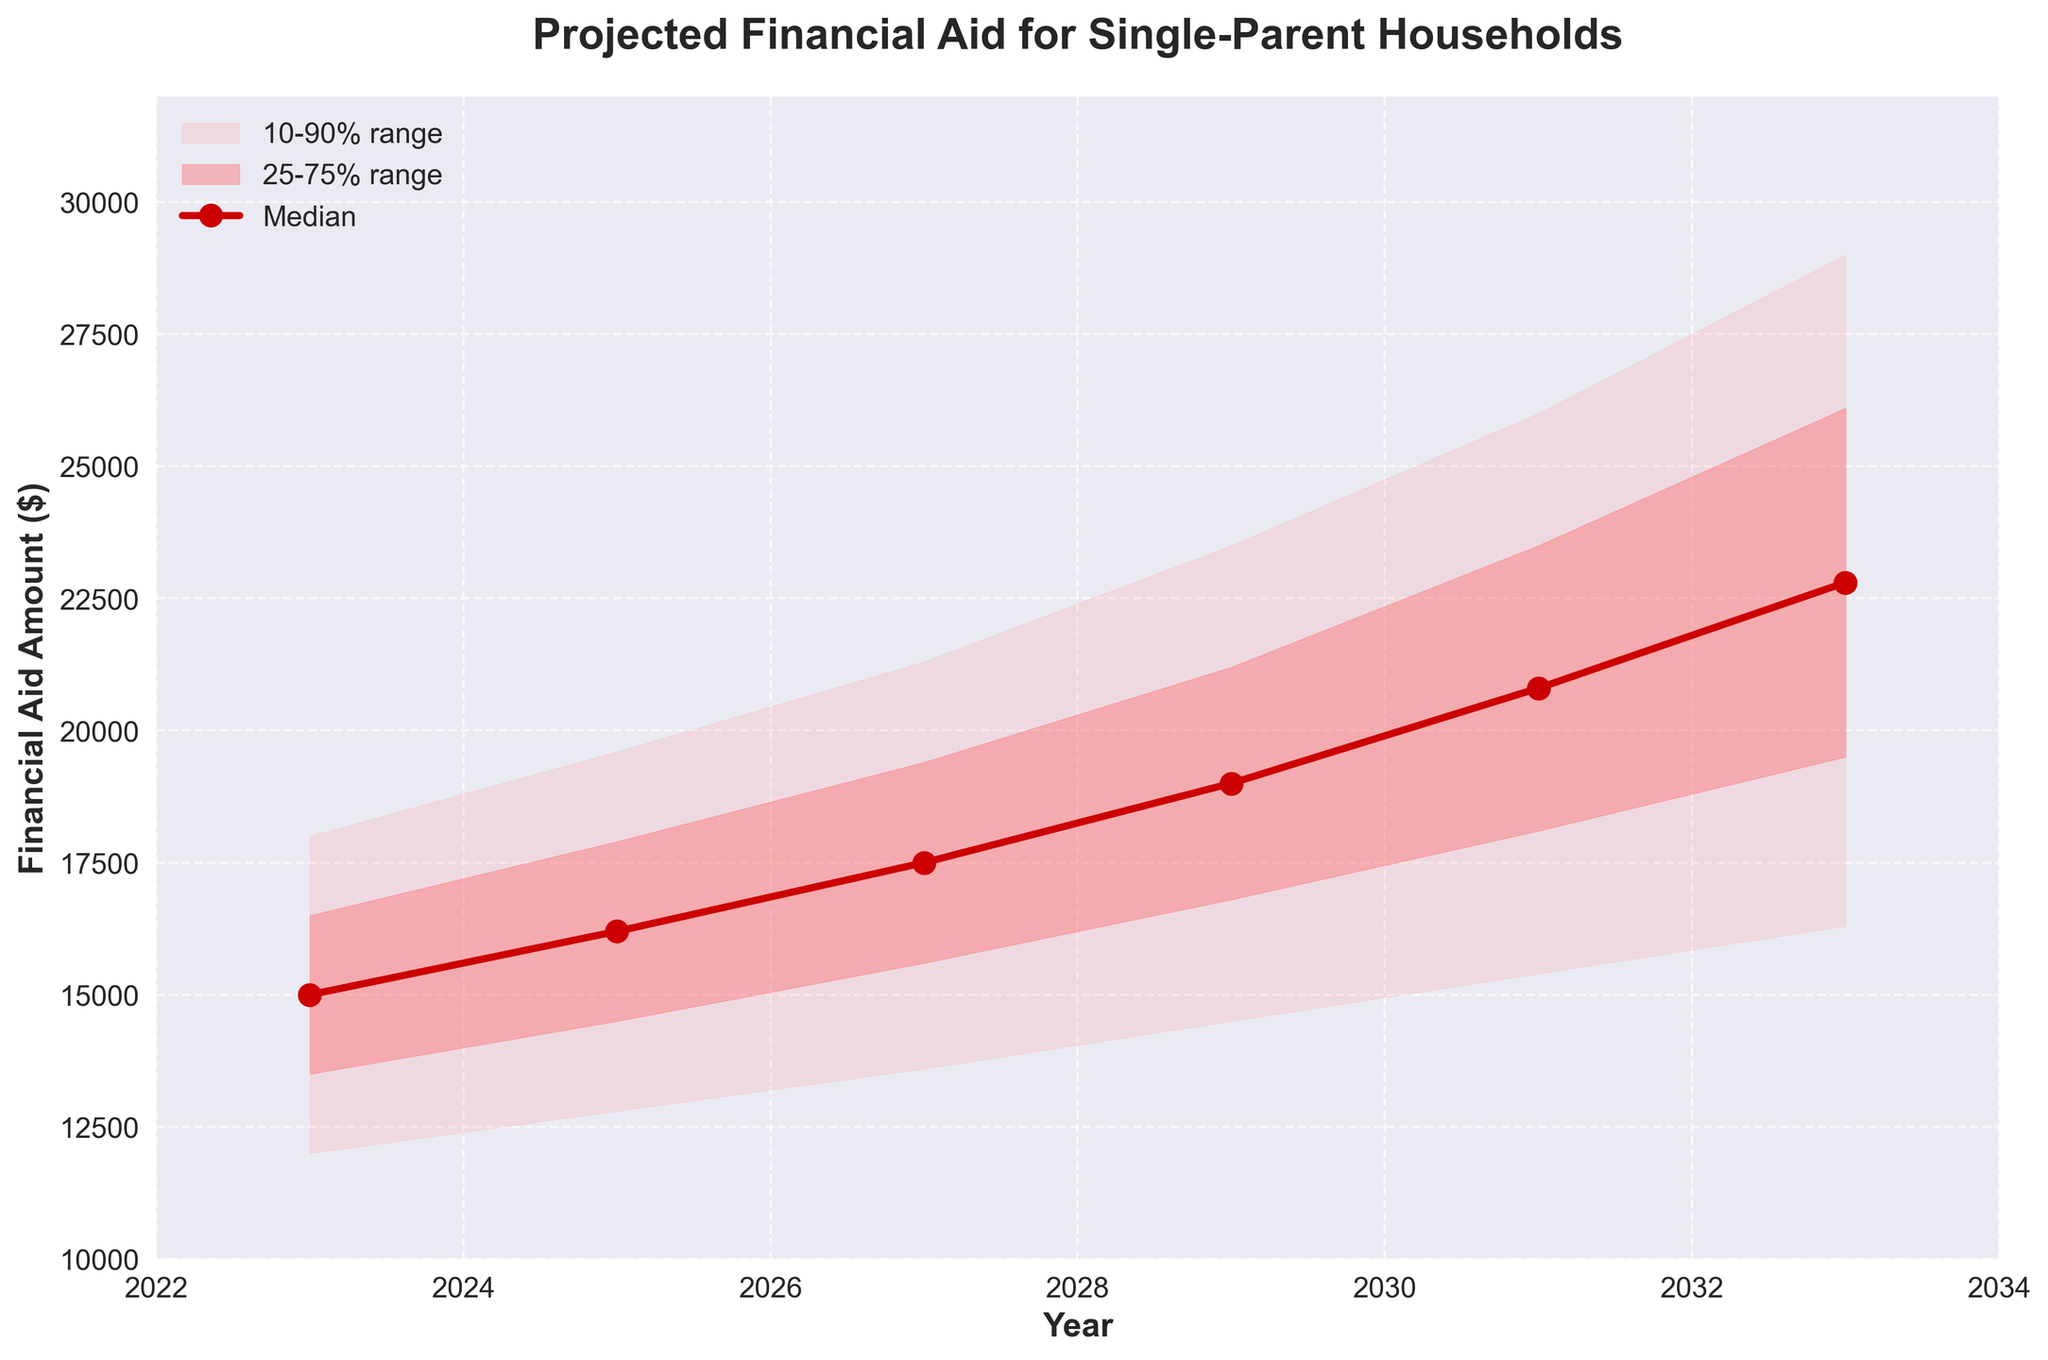What is the title of the chart? The title is located at the top of the chart, specifying the main focus of the visualization.
Answer: Projected Financial Aid for Single-Parent Households What is the projected median financial aid amount in 2027? The median value line is marked with a distinct color and symbol, and the label on the Y-axis helps in identifying the value corresponding to 2027.
Answer: $17,500 By how much is the median financial aid amount expected to increase from 2023 to 2033? The median values for 2023 and 2033 need to be identified and then subtracted: $22,800 (2033) - $15,000 (2023).
Answer: $7,800 What range encompasses the middle 50% of the projected financial aid amounts in 2029? The middle 50% range is between the 25th and 75th percentiles. Look at the values for 2029 under the 25% and 75% columns: $16,800 to $21,200.
Answer: $16,800 to $21,200 Which year shows the highest projected upper limit for the 90% range? Compare the upper 90% values for all the years. The highest value will indicate the answer.
Answer: 2033 How does the lower 10% limit in 2023 compare to the median in 2031? Identify the lower 10% limit in 2023 and the median in 2031, then compare these values. $12,000 (2023) vs. $20,800 (2031).
Answer: The median in 2031 is higher What is the projected financial aid range for the 75th to 90th percentile in 2025? Subtract the 75th percentile from the 90th percentile for the year 2025. $19,600 (90%) - $17,900 (75%).
Answer: $1,700 In which year does the median financial aid exceed $20,000? Identify the years from the median values where the financial aid surpasses $20,000. It happens after checking the median values for each year up to 2031 and beyond.
Answer: 2031 What is the difference between the highest upper 90% value and the lowest lower 10% value across all years? Identify the highest value from the upper 90% column and the lowest value from the lower 10% column, then subtract. $29,000 (highest) - $12,000 (lowest).
Answer: $17,000 